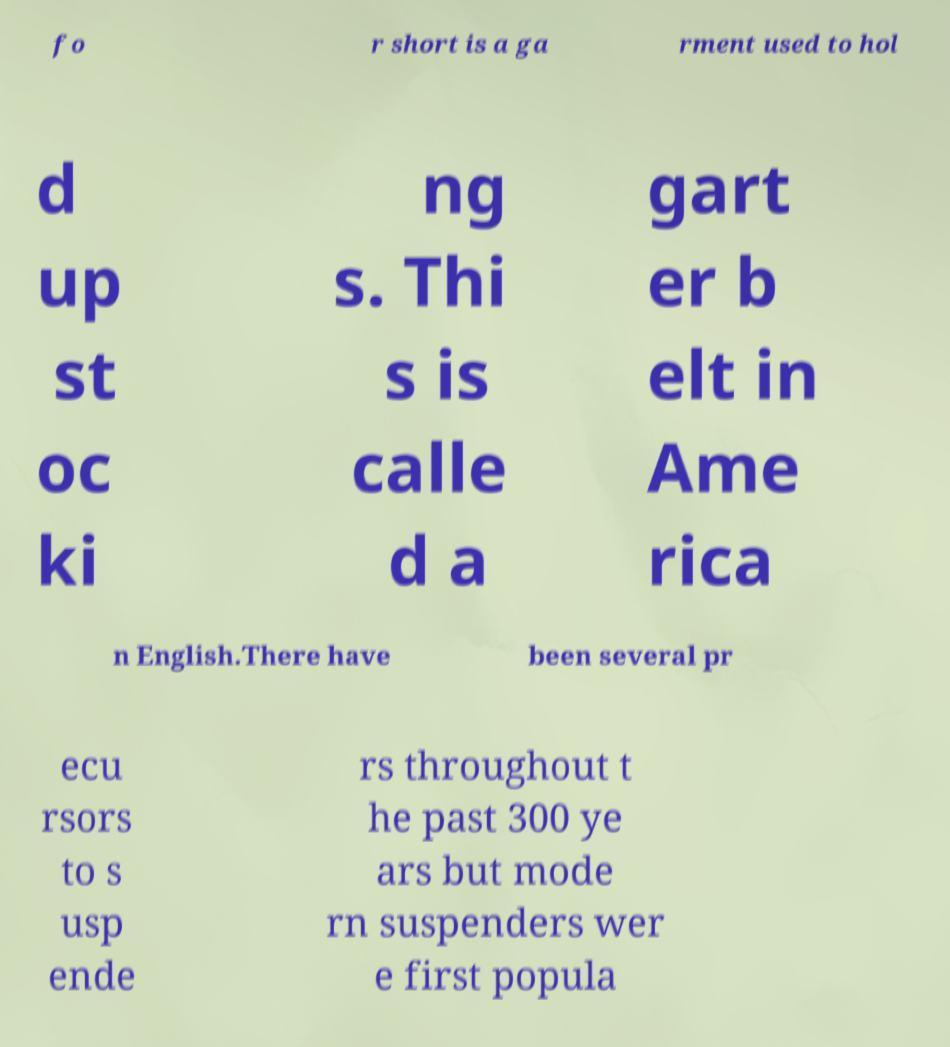I need the written content from this picture converted into text. Can you do that? fo r short is a ga rment used to hol d up st oc ki ng s. Thi s is calle d a gart er b elt in Ame rica n English.There have been several pr ecu rsors to s usp ende rs throughout t he past 300 ye ars but mode rn suspenders wer e first popula 